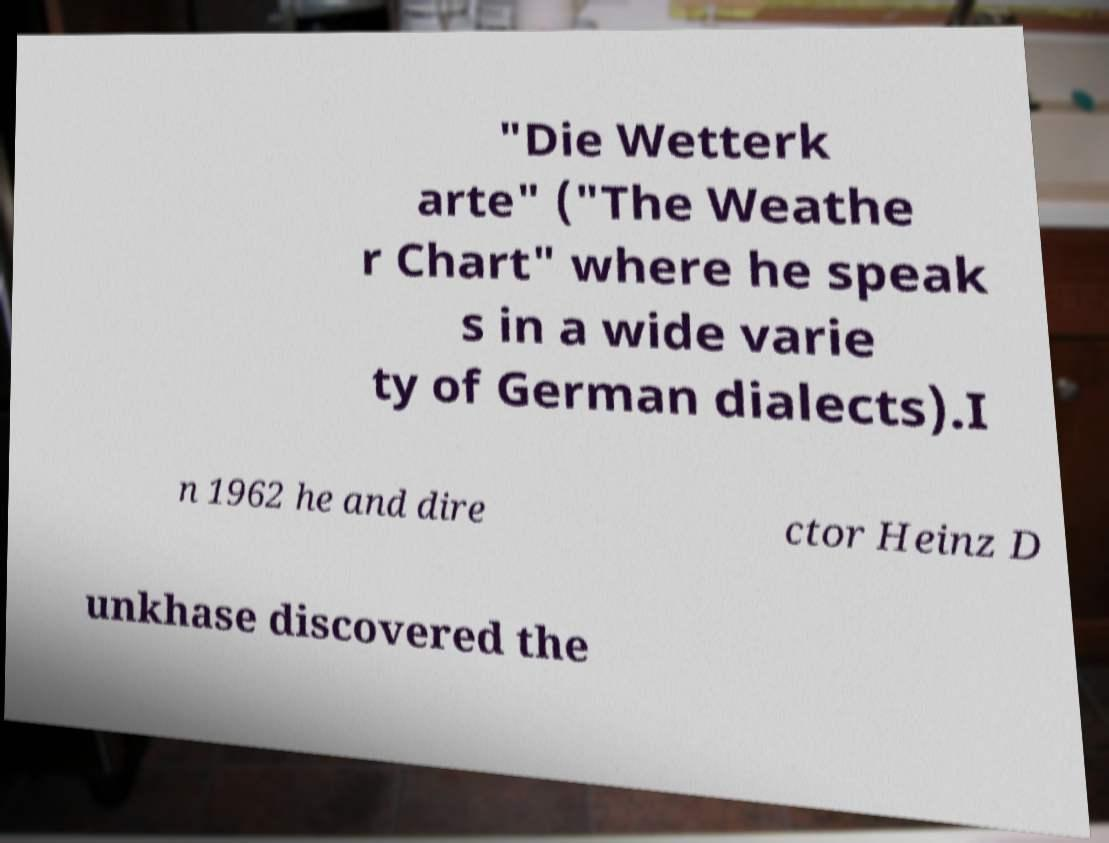For documentation purposes, I need the text within this image transcribed. Could you provide that? "Die Wetterk arte" ("The Weathe r Chart" where he speak s in a wide varie ty of German dialects).I n 1962 he and dire ctor Heinz D unkhase discovered the 